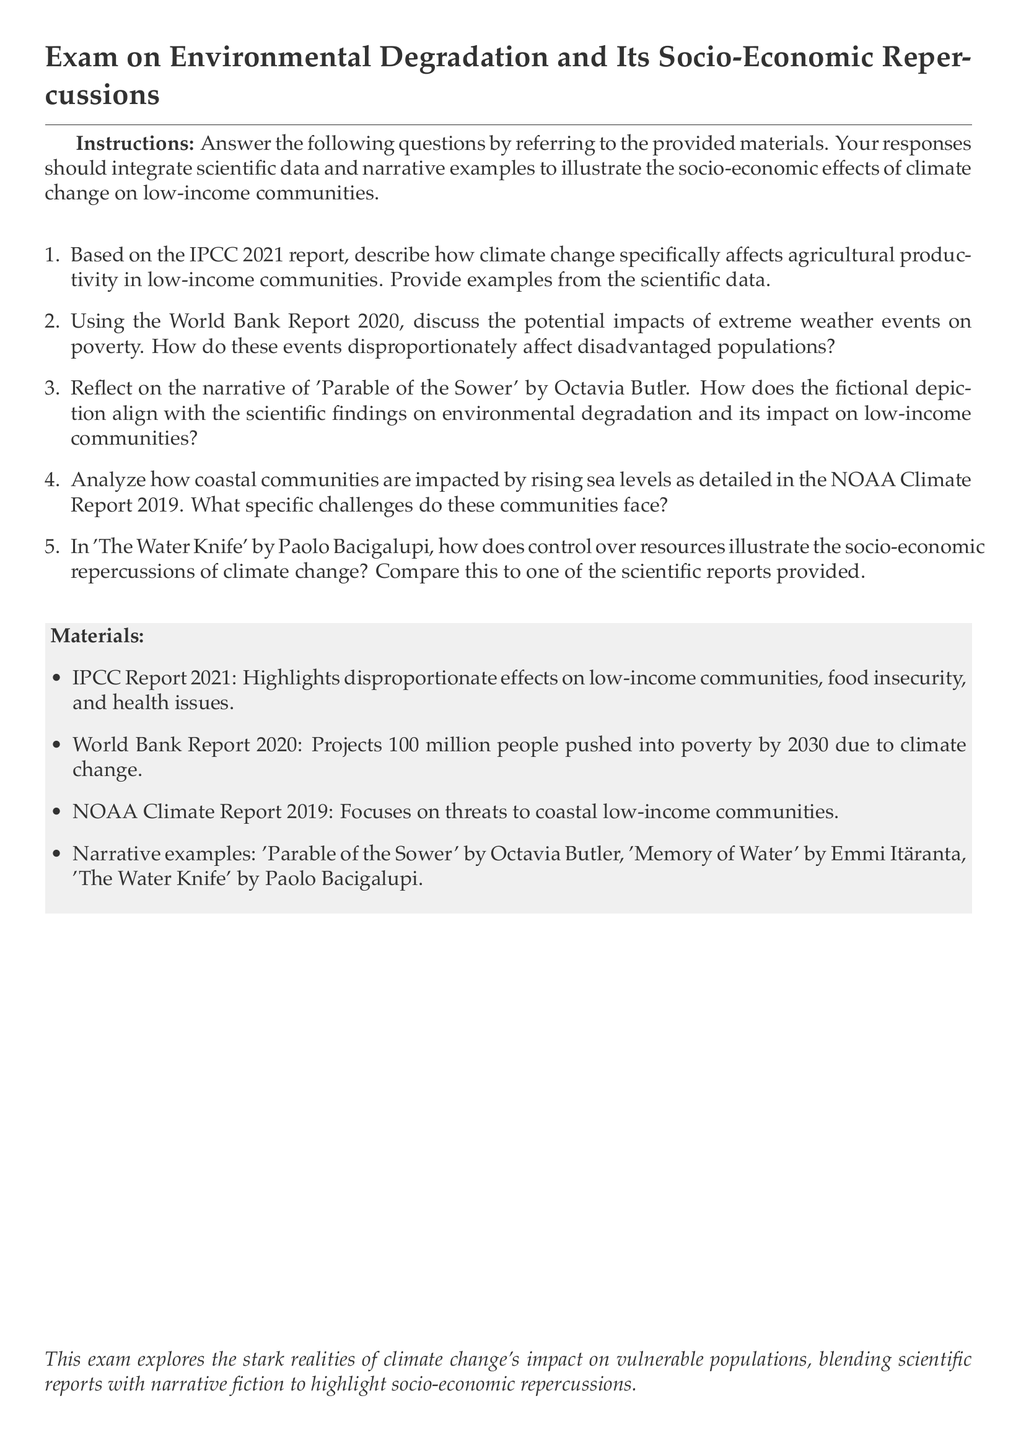What is the main title of the document? The title summarizes the focus of the exam on climate change's socio-economic impacts.
Answer: Exam on Environmental Degradation and Its Socio-Economic Repercussions How many reports are cited in the materials? The materials section lists four specific reports covering relevant data and narratives.
Answer: 4 Which fictional work is mentioned alongside its author in the document? The document references the narrative work of Octavia Butler as part of the exam materials.
Answer: Parable of the Sower by Octavia Butler According to the World Bank Report 2020, how many people are projected to be pushed into poverty by 2030 due to climate change? The specific figure is highlighted in the context of socio-economic impacts discussed in the report.
Answer: 100 million What year does the NOAA Climate Report focus on to detail the threats to coastal low-income communities? The document provides a specific year when addressing the challenges faced by these communities.
Answer: 2019 Which report emphasizes health issues as a result of climate change? The IPCC Report 2021 discusses various consequences of climate change, including health impacts.
Answer: IPCC Report 2021 What challenges do coastal communities face according to the NOAA Climate Report? The question prompts a reflection on the specific difficulties highlighted in the report.
Answer: Rising sea levels Name one of the narrative examples listed in the document. The document provides a list of narrative works that explore themes of environmental degradation.
Answer: The Water Knife 